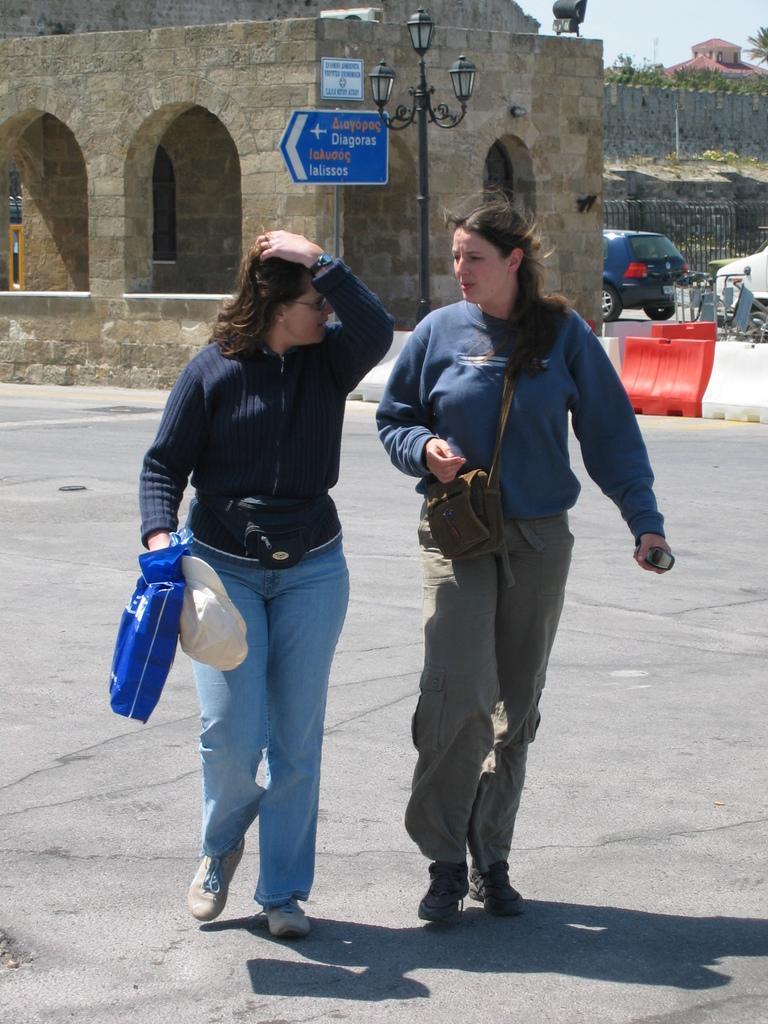Describe this image in one or two sentences. The picture is taken outside a city, on the road. In the foreground of the picture there are two women walking. In the center of the picture there are street light, sign board and a building. In the background there are cars, railing, grass, plants and building. It is Sunny. 